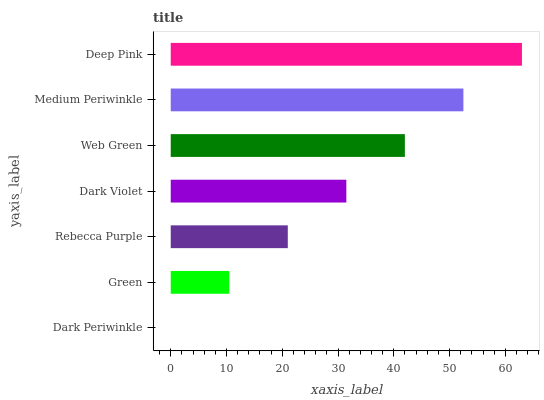Is Dark Periwinkle the minimum?
Answer yes or no. Yes. Is Deep Pink the maximum?
Answer yes or no. Yes. Is Green the minimum?
Answer yes or no. No. Is Green the maximum?
Answer yes or no. No. Is Green greater than Dark Periwinkle?
Answer yes or no. Yes. Is Dark Periwinkle less than Green?
Answer yes or no. Yes. Is Dark Periwinkle greater than Green?
Answer yes or no. No. Is Green less than Dark Periwinkle?
Answer yes or no. No. Is Dark Violet the high median?
Answer yes or no. Yes. Is Dark Violet the low median?
Answer yes or no. Yes. Is Rebecca Purple the high median?
Answer yes or no. No. Is Dark Periwinkle the low median?
Answer yes or no. No. 